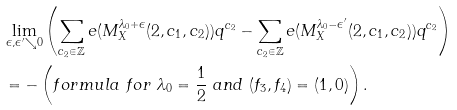Convert formula to latex. <formula><loc_0><loc_0><loc_500><loc_500>& \lim _ { \epsilon , \epsilon ^ { \prime } \searrow 0 } \left ( \sum _ { c _ { 2 } \in \mathbb { Z } } e ( M _ { X } ^ { \lambda _ { 0 } + \epsilon } ( 2 , c _ { 1 } , c _ { 2 } ) ) q ^ { c _ { 2 } } - \sum _ { c _ { 2 } \in \mathbb { Z } } e ( M _ { X } ^ { \lambda _ { 0 } - \epsilon ^ { \prime } } ( 2 , c _ { 1 } , c _ { 2 } ) ) q ^ { c _ { 2 } } \right ) \\ & = - \left ( f o r m u l a \ f o r \ \lambda _ { 0 } = \frac { 1 } { 2 } \ a n d \ ( f _ { 3 } , f _ { 4 } ) = ( 1 , 0 ) \right ) .</formula> 